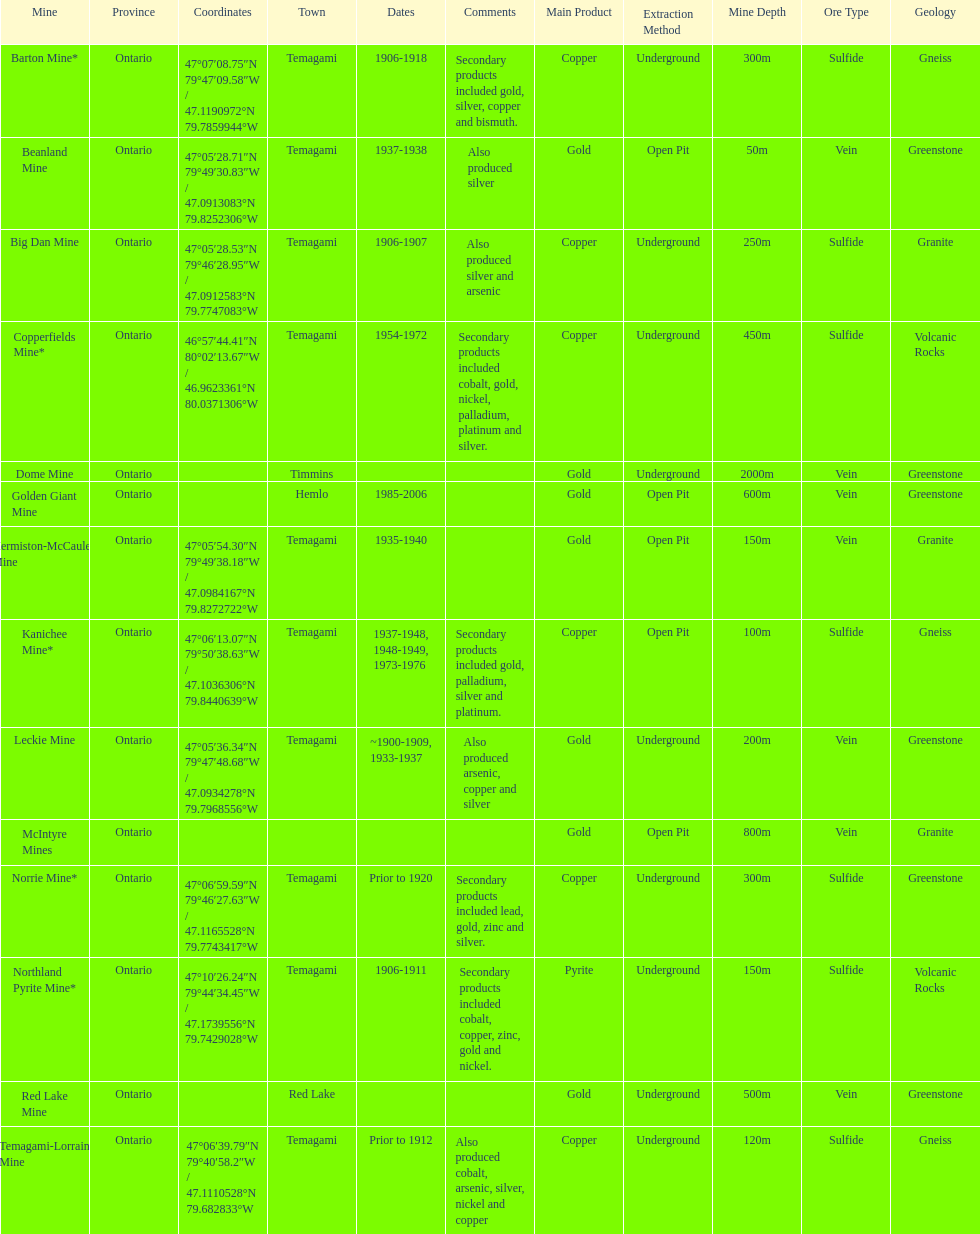What province is the town of temagami? Ontario. 